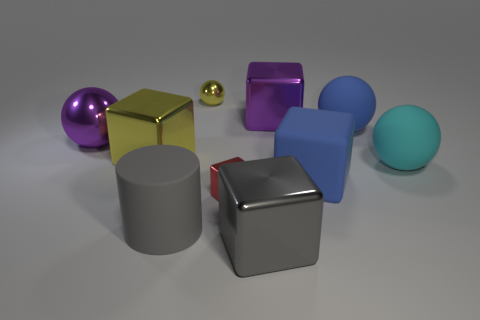Are there the same number of shiny objects in front of the cylinder and tiny balls?
Your response must be concise. Yes. Are there any other things that are the same material as the red thing?
Offer a terse response. Yes. Does the large purple thing to the left of the large gray block have the same material as the tiny red object?
Your answer should be compact. Yes. Are there fewer large matte balls in front of the tiny cube than small metal balls?
Provide a short and direct response. Yes. How many matte things are either spheres or small yellow things?
Ensure brevity in your answer.  2. Is the color of the cylinder the same as the small block?
Offer a terse response. No. Is there any other thing that has the same color as the tiny sphere?
Offer a very short reply. Yes. There is a big gray thing that is behind the gray metal cube; is it the same shape as the yellow metallic object that is on the left side of the big cylinder?
Ensure brevity in your answer.  No. How many objects are either purple cubes or large spheres to the right of the large blue matte sphere?
Your answer should be very brief. 2. What number of other things are there of the same size as the red metal thing?
Your answer should be very brief. 1. 